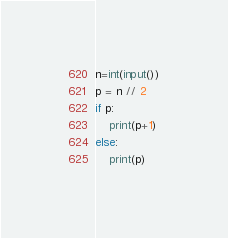<code> <loc_0><loc_0><loc_500><loc_500><_Python_>n=int(input())
p = n // 2
if p:
    print(p+1)
else:
    print(p)</code> 